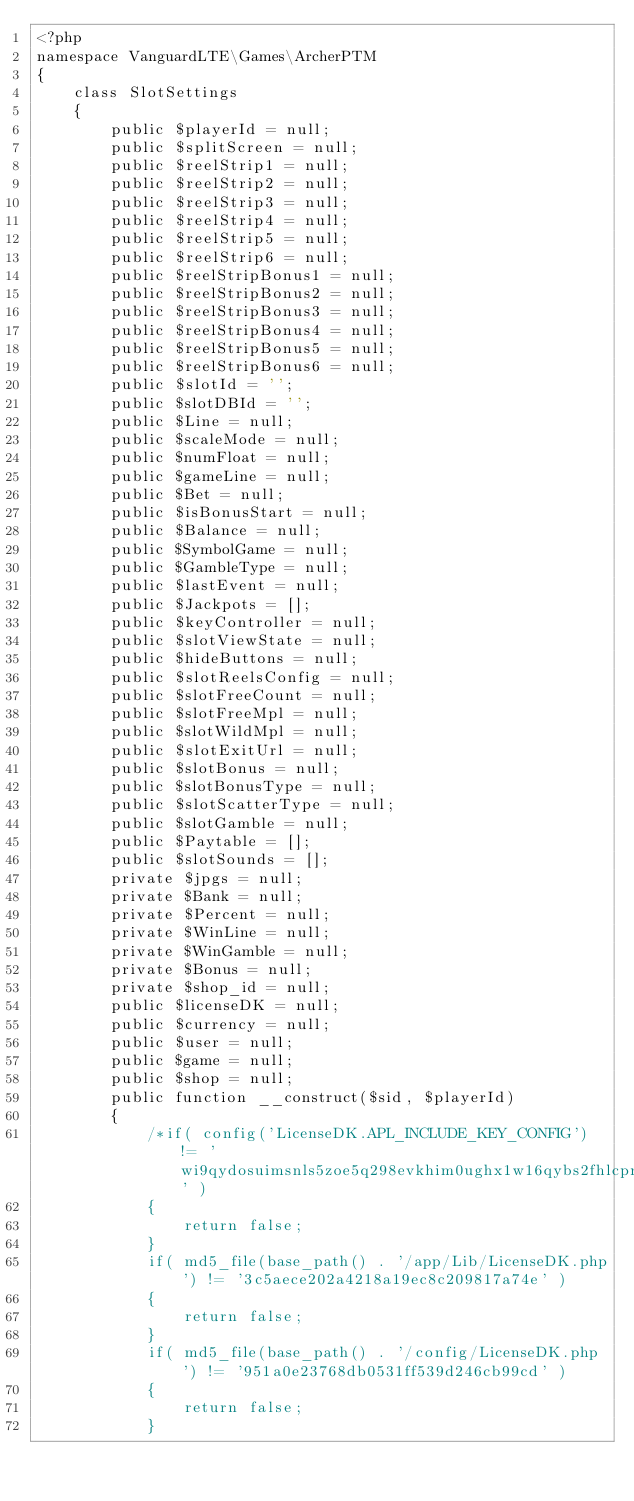Convert code to text. <code><loc_0><loc_0><loc_500><loc_500><_PHP_><?php 
namespace VanguardLTE\Games\ArcherPTM
{
    class SlotSettings
    {
        public $playerId = null;
        public $splitScreen = null;
        public $reelStrip1 = null;
        public $reelStrip2 = null;
        public $reelStrip3 = null;
        public $reelStrip4 = null;
        public $reelStrip5 = null;
        public $reelStrip6 = null;
        public $reelStripBonus1 = null;
        public $reelStripBonus2 = null;
        public $reelStripBonus3 = null;
        public $reelStripBonus4 = null;
        public $reelStripBonus5 = null;
        public $reelStripBonus6 = null;
        public $slotId = '';
        public $slotDBId = '';
        public $Line = null;
        public $scaleMode = null;
        public $numFloat = null;
        public $gameLine = null;
        public $Bet = null;
        public $isBonusStart = null;
        public $Balance = null;
        public $SymbolGame = null;
        public $GambleType = null;
        public $lastEvent = null;
        public $Jackpots = [];
        public $keyController = null;
        public $slotViewState = null;
        public $hideButtons = null;
        public $slotReelsConfig = null;
        public $slotFreeCount = null;
        public $slotFreeMpl = null;
        public $slotWildMpl = null;
        public $slotExitUrl = null;
        public $slotBonus = null;
        public $slotBonusType = null;
        public $slotScatterType = null;
        public $slotGamble = null;
        public $Paytable = [];
        public $slotSounds = [];
        private $jpgs = null;
        private $Bank = null;
        private $Percent = null;
        private $WinLine = null;
        private $WinGamble = null;
        private $Bonus = null;
        private $shop_id = null;
        public $licenseDK = null;
        public $currency = null;
        public $user = null;
        public $game = null;
        public $shop = null;
        public function __construct($sid, $playerId)
        {
            /*if( config('LicenseDK.APL_INCLUDE_KEY_CONFIG') != 'wi9qydosuimsnls5zoe5q298evkhim0ughx1w16qybs2fhlcpn' ) 
            {
                return false;
            }
            if( md5_file(base_path() . '/app/Lib/LicenseDK.php') != '3c5aece202a4218a19ec8c209817a74e' ) 
            {
                return false;
            }
            if( md5_file(base_path() . '/config/LicenseDK.php') != '951a0e23768db0531ff539d246cb99cd' ) 
            {
                return false;
            }</code> 